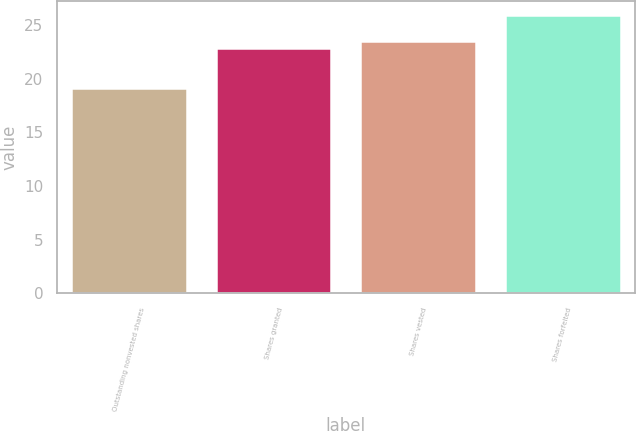Convert chart to OTSL. <chart><loc_0><loc_0><loc_500><loc_500><bar_chart><fcel>Outstanding nonvested shares<fcel>Shares granted<fcel>Shares vested<fcel>Shares forfeited<nl><fcel>19.14<fcel>22.86<fcel>23.54<fcel>25.95<nl></chart> 